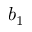Convert formula to latex. <formula><loc_0><loc_0><loc_500><loc_500>b _ { 1 }</formula> 